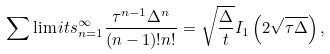Convert formula to latex. <formula><loc_0><loc_0><loc_500><loc_500>\sum \lim i t s _ { n = 1 } ^ { \infty } \frac { \tau ^ { n - 1 } \Delta ^ { n } } { ( n - 1 ) ! n ! } = \sqrt { \frac { \Delta } { t } } I _ { 1 } \left ( 2 \sqrt { \tau \Delta } \right ) ,</formula> 